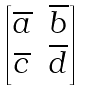<formula> <loc_0><loc_0><loc_500><loc_500>\begin{bmatrix} \overline { a } & \overline { b } \\ \overline { c } & \overline { d } \end{bmatrix}</formula> 